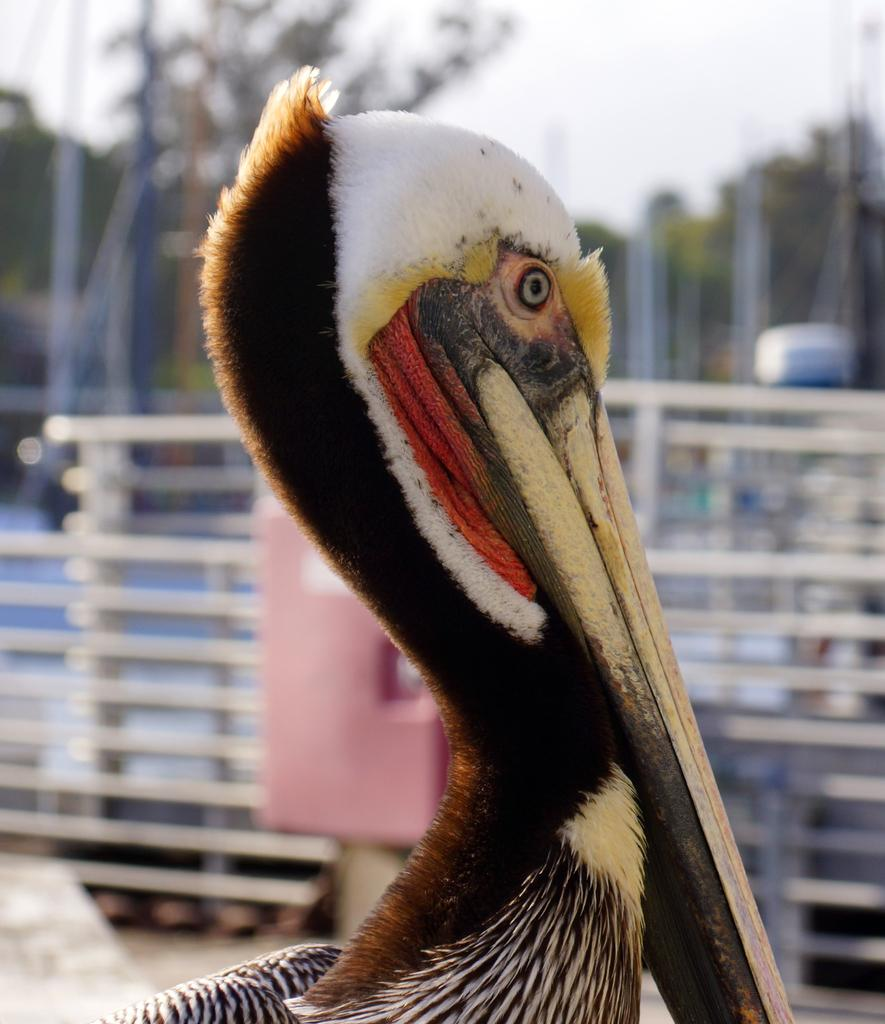What type of bird is in the image? There is a pelican bird in the image. What is located behind the bird? There is a railing behind the bird. What can be seen at the top of the image? The sky is visible at the top of the image. How would you describe the background of the image? The background of the image is blurry. What is the bird teaching in the image? There is no indication in the image that the bird is teaching anything. 